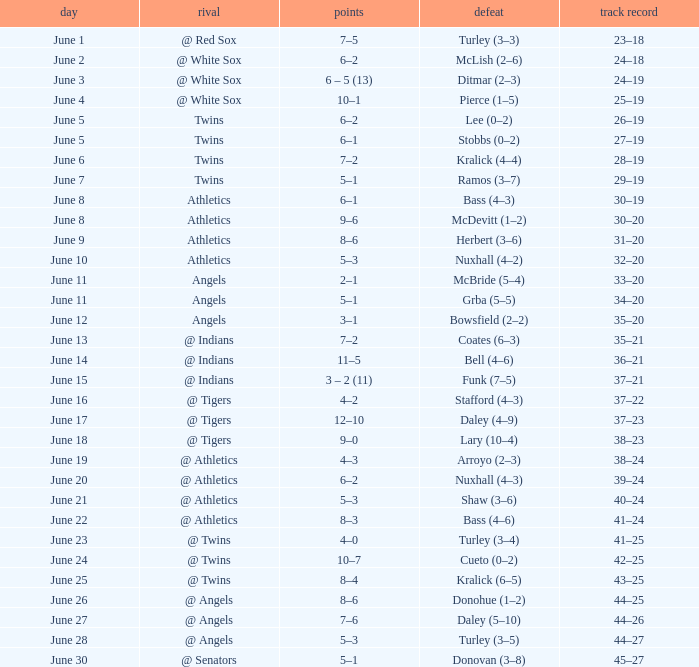What was the score from the game played on June 22? 8–3. 